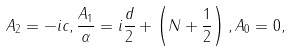Convert formula to latex. <formula><loc_0><loc_0><loc_500><loc_500>A _ { 2 } = - i c , \frac { A _ { 1 } } { \alpha } = i \frac { d } { 2 } + \left ( N + \frac { 1 } { 2 } \right ) , A _ { 0 } = 0 ,</formula> 